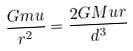Convert formula to latex. <formula><loc_0><loc_0><loc_500><loc_500>\frac { G m u } { r ^ { 2 } } = \frac { 2 G M u r } { d ^ { 3 } }</formula> 